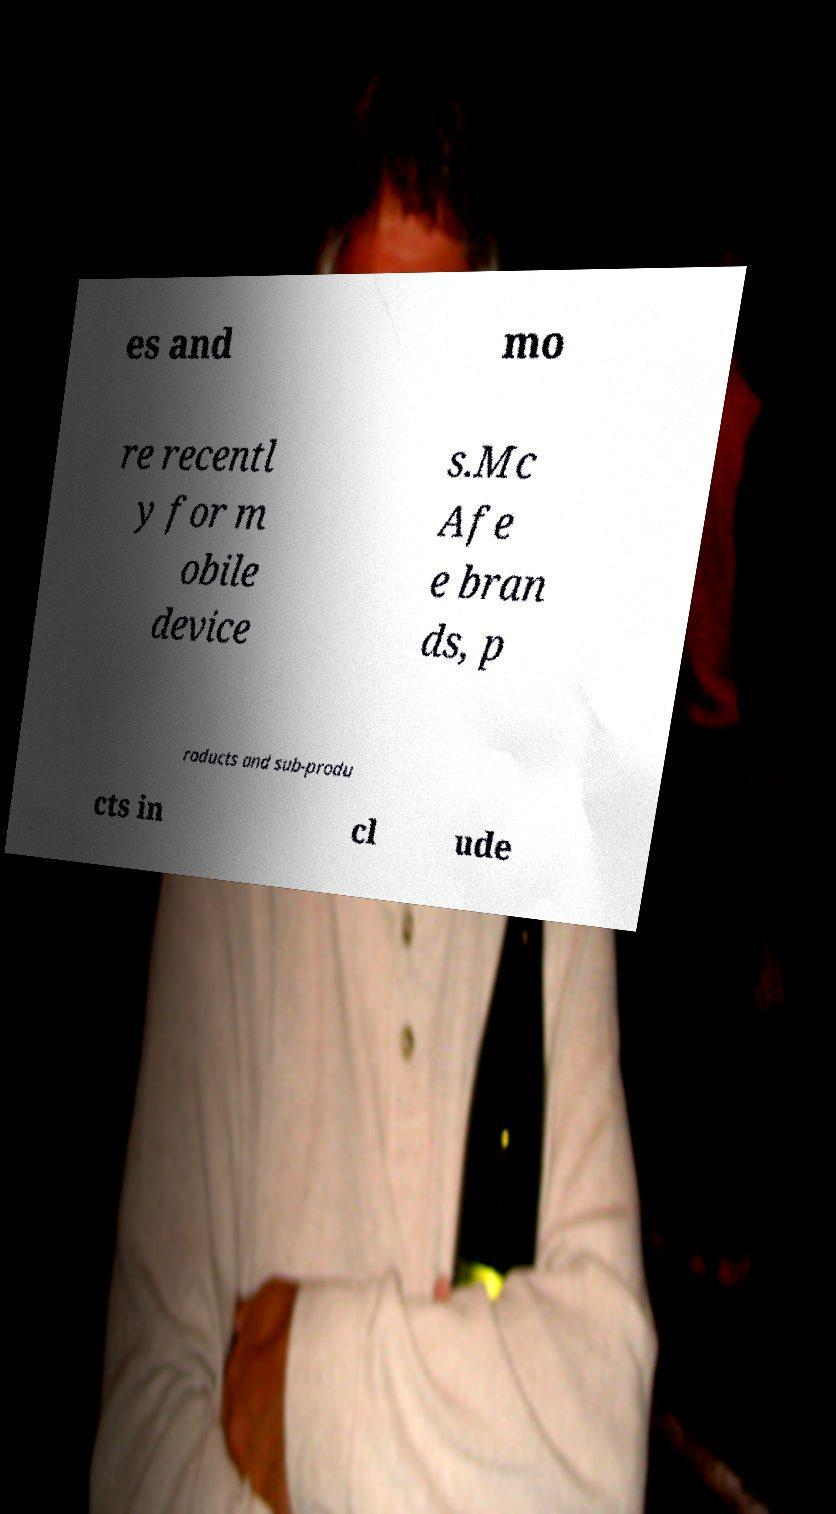Can you read and provide the text displayed in the image?This photo seems to have some interesting text. Can you extract and type it out for me? es and mo re recentl y for m obile device s.Mc Afe e bran ds, p roducts and sub-produ cts in cl ude 